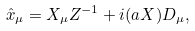Convert formula to latex. <formula><loc_0><loc_0><loc_500><loc_500>\hat { x } _ { \mu } = X _ { \mu } Z ^ { - 1 } + i ( a X ) D _ { \mu } ,</formula> 